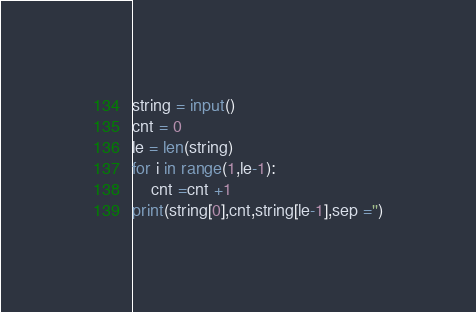Convert code to text. <code><loc_0><loc_0><loc_500><loc_500><_Python_>string = input()
cnt = 0
le = len(string)
for i in range(1,le-1):
    cnt =cnt +1
print(string[0],cnt,string[le-1],sep ='')</code> 